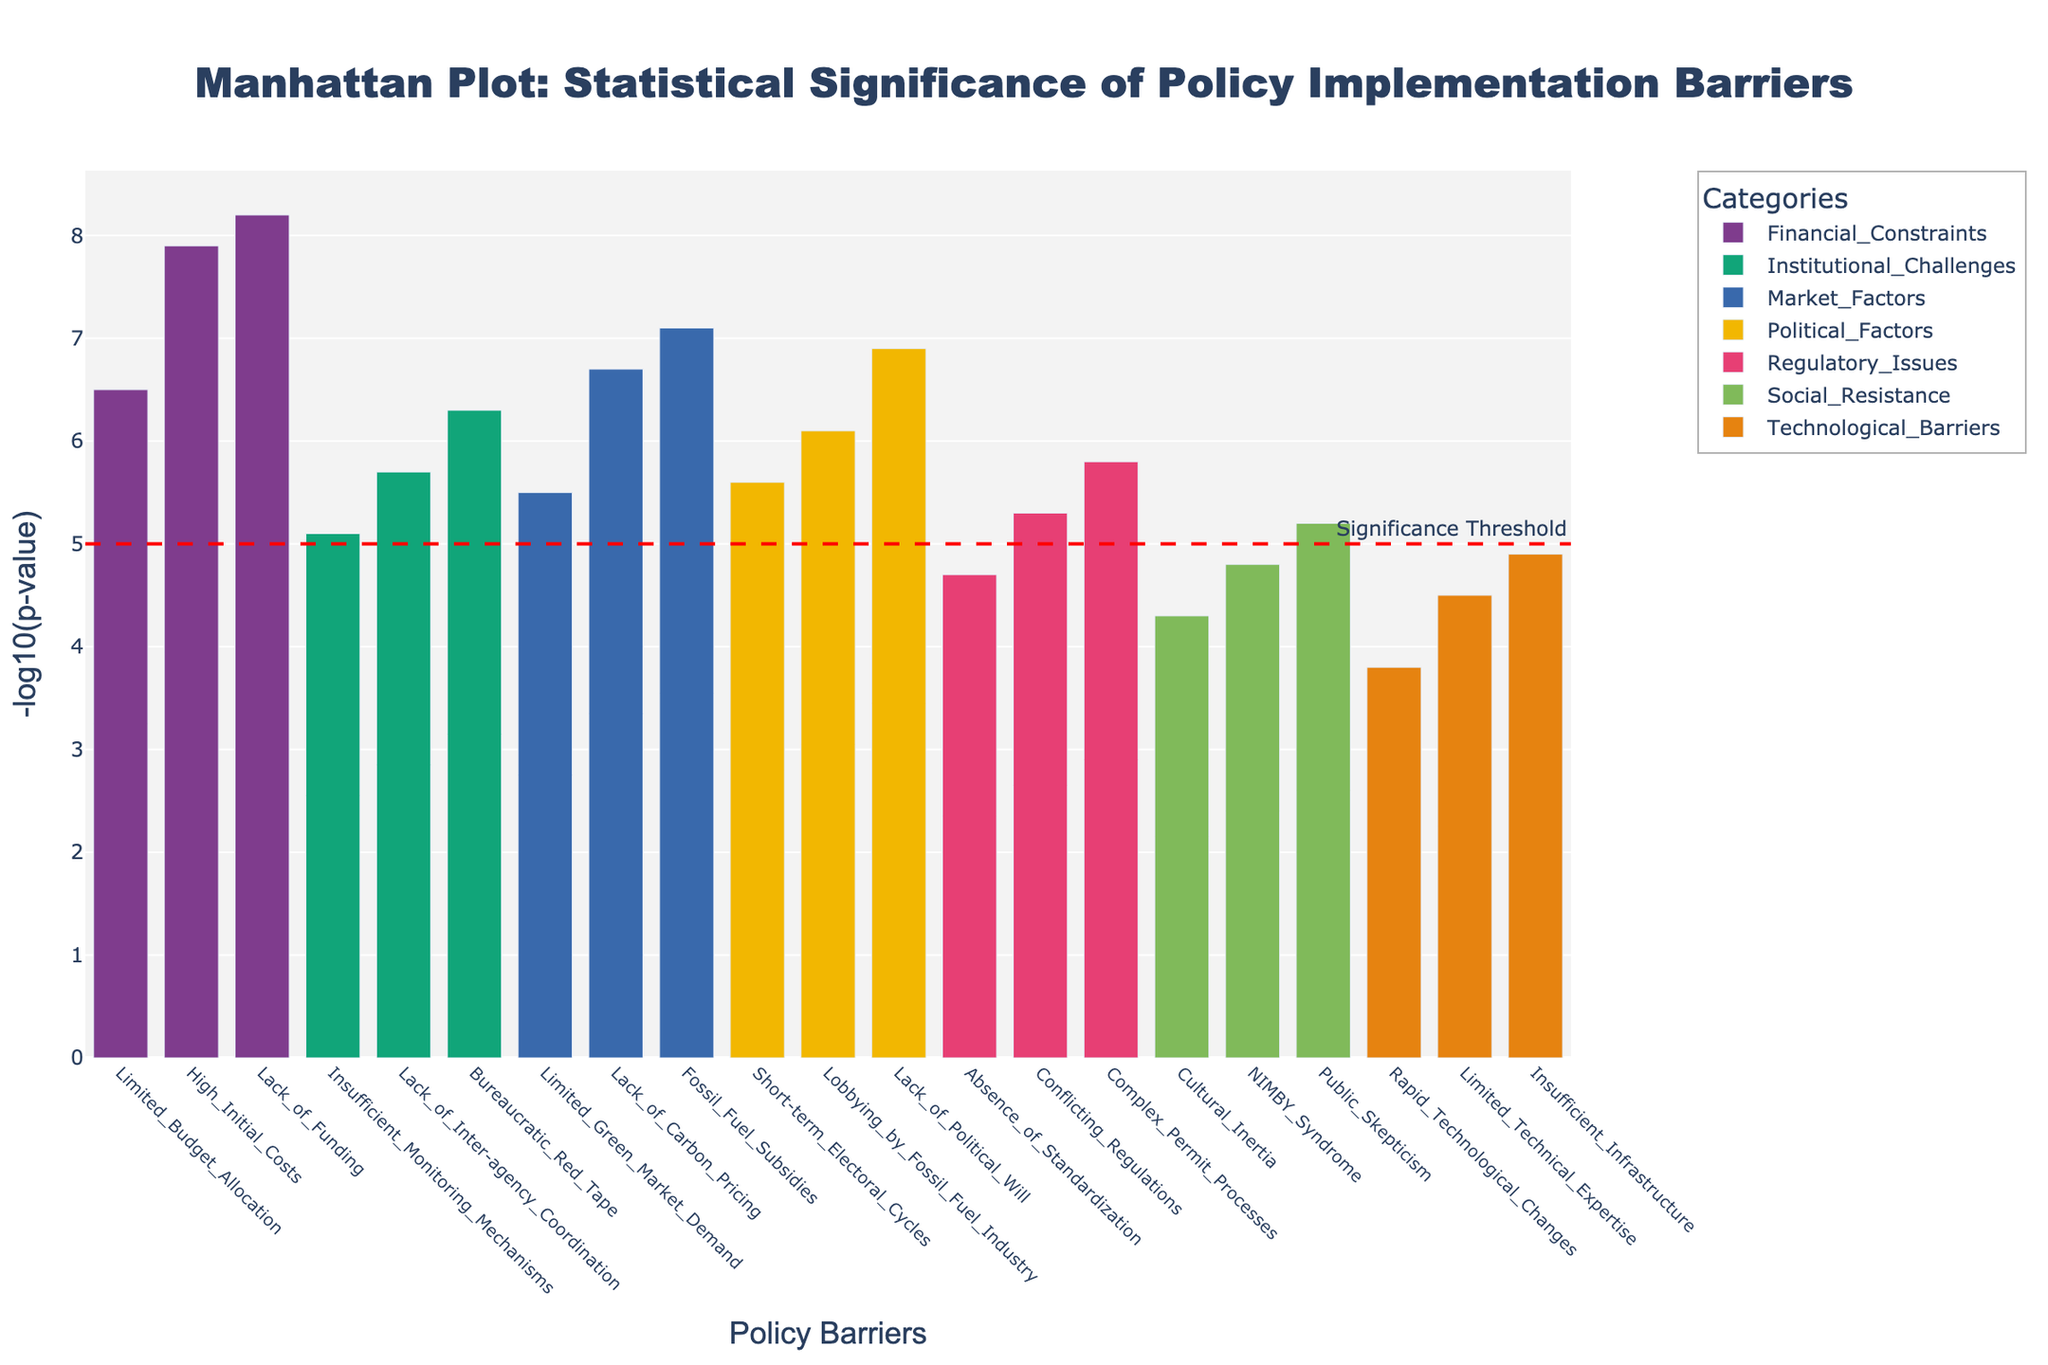What's the title of the plot? The title of the plot is usually located at the top center. In this case, it reads "Manhattan Plot: Statistical Significance of Policy Implementation Barriers".
Answer: Manhattan Plot: Statistical Significance of Policy Implementation Barriers How many policy barriers are listed under Social Resistance? Under Social Resistance, count the distinct policy barriers present. They are Public Skepticism, NIMBY Syndrome, and Cultural Inertia, making it a total of 3.
Answer: 3 Which policy barrier has the highest statistical significance and under which category does it fall? Look for the tallest bar in the plot, which corresponds to the highest -log10(p-value). The highest bar is Lack of Funding under Financial Constraints.
Answer: Lack of Funding, Financial Constraints What is the -log10(p-value) of Complex Permit Processes and how is it visually highlighted in the plot? Find the bar corresponding to Complex Permit Processes along the x-axis and check its height along the y-axis. Its -log10(p-value) is 5.8.
Answer: 5.8 Which category has a barrier with a significance below the threshold line (set at y=5)? Identify the category with any bar whose height is below the red threshold line (y=5). In this plot, Technological Barriers and Social Resistance categories have barriers below this threshold.
Answer: Technological Barriers, Social Resistance Compare the statistical significance of Lobbying by Fossil Fuel Industry and Lack of Inter-agency Coordination. Which one is more significant? Locate both bars on the plot and compare their heights. Lobbying by Fossil Fuel Industry has a -log10(p-value) of 6.1, while Lack of Inter-agency Coordination has 5.7. Thus, Lobbying by Fossil Fuel Industry is more significant.
Answer: Lobbying by Fossil Fuel Industry Calculate the average -log10(p-value) for the barriers under Market Factors. Note the -log10(p-values) for barriers under Market Factors (7.1, 6.7, and 5.5). Sum them up (7.1+6.7+5.5 = 19.3) and divide by 3. The average is 19.3/3 = 6.43.
Answer: 6.43 Which policy barrier has the lowest statistical significance, and what is its -log10(p-value)? Identify the shortest bar in the plot, representing the lowest -log10(p-value). It is Rapid Technological Changes in the Technological Barriers category with a -log10(p-value) of 3.8.
Answer: Rapid Technological Changes, 3.8 How many categories have at least one policy barrier with a -log10(p-value) greater than 6.5? Check each category to see if it contains a bar with a height greater than 6.5. Financial Constraints, Political Factors, and Market Factors all have such bars, totaling 3 categories.
Answer: 3 